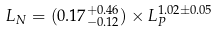Convert formula to latex. <formula><loc_0><loc_0><loc_500><loc_500>L _ { N } = ( 0 . 1 7 ^ { + 0 . 4 6 } _ { - 0 . 1 2 } ) \times L _ { P } ^ { 1 . 0 2 \pm 0 . 0 5 }</formula> 